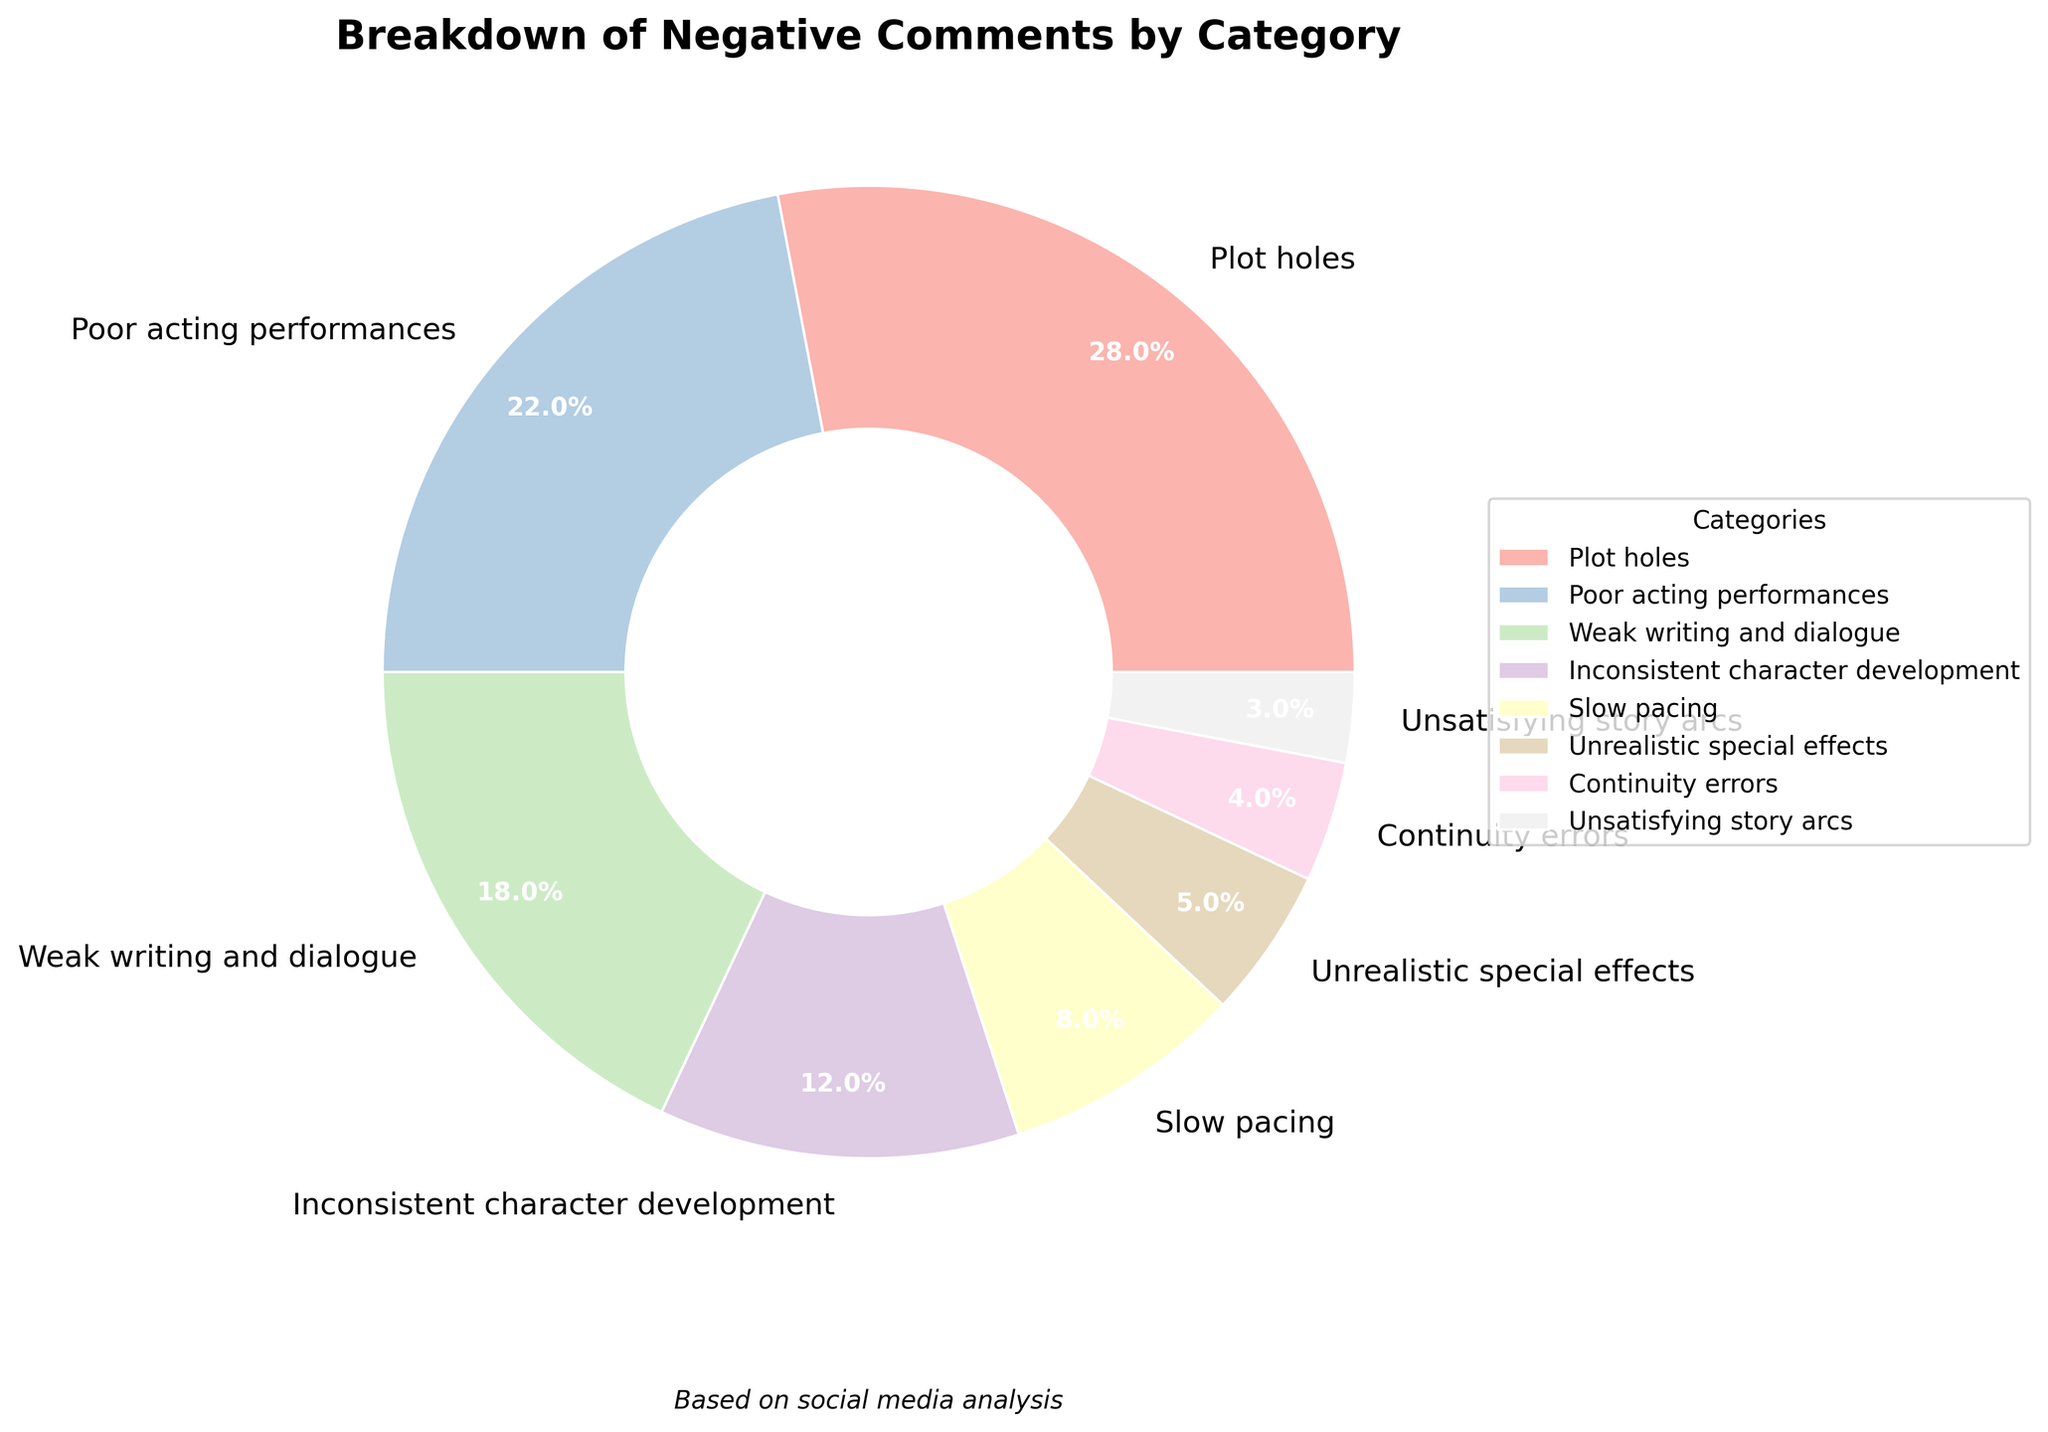What's the total percentage of negative comments accounted for by 'Plot holes' and 'Poor acting performances'? Add the percentages for 'Plot holes' (28%) and 'Poor acting performances' (22%). 28 + 22 = 50.
Answer: 50% Which category has the least amount of negative comments? Identify the category with the smallest percentage. 'Unsatisfying story arcs' has 3%, which is the smallest.
Answer: Unsatisfying story arcs Are 'Plot holes' more frequently mentioned than 'Slow pacing'? Compare the percentages. 'Plot holes' have 28%, while 'Slow pacing' has 8%. 28% is greater than 8%.
Answer: Yes What is the difference in the percentage of negative comments between 'Inconsistent character development' and 'Weak writing and dialogue'? Subtract the percentage of 'Weak writing and dialogue' (18%) from 'Inconsistent character development' (12%). 18 - 12 = 6.
Answer: 6% What proportion of negative comments (in percentage) is due to 'Unrealistic special effects' compared to 'Continuity errors'? Divide the percentage of 'Unrealistic special effects' (5%) by 'Continuity errors' (4%) and multiply by 100 to get the proportion. (5/4) * 100 = 125%.
Answer: 125% Which categories collectively make up more than half of the negative comments? Add the percentages of the largest categories until the total exceeds 50%. 'Plot holes' (28%), 'Poor acting performances' (22%), and 'Weak writing and dialogue' (18%) together total 28 + 22 + 18 = 68%.
Answer: Plot holes, Poor acting performances, Weak writing and dialogue How many categories have more than 10% of the negative comments? Identify and count categories with percentages above 10%. 'Plot holes' (28%), 'Poor acting performances' (22%), 'Weak writing and dialogue' (18%), 'Inconsistent character development' (12%). There are four such categories.
Answer: 4 If you combine 'Plot holes', 'Poor acting performances', and 'Weak writing and dialogue', what is their combined percentage? Sum the percentages of 'Plot holes' (28%), 'Poor acting performances' (22%), and 'Weak writing and dialogue' (18%). 28 + 22 + 18 = 68.
Answer: 68% Compare the percentage of 'Slow pacing' comments to the combined percentage of 'Unrealistic special effects' and 'Continuity errors.' Which is higher? 'Slow pacing' has 8%. 'Unrealistic special effects' (5%) + 'Continuity errors' (4%) is 9%. So, 8% < 9%.
Answer: Combined 'Unrealistic special effects' and 'Continuity errors' is higher What percentage of the total negative comments are accounted for by categories other than the top three? Find the sum of all percentages and subtract the sum of the top three categories. Total = 100%. Sum of top three ('Plot holes' 28%, 'Poor acting performances' 22%, 'Weak writing and dialogue' 18%) = 68%. 100% - 68% = 32%.
Answer: 32% 